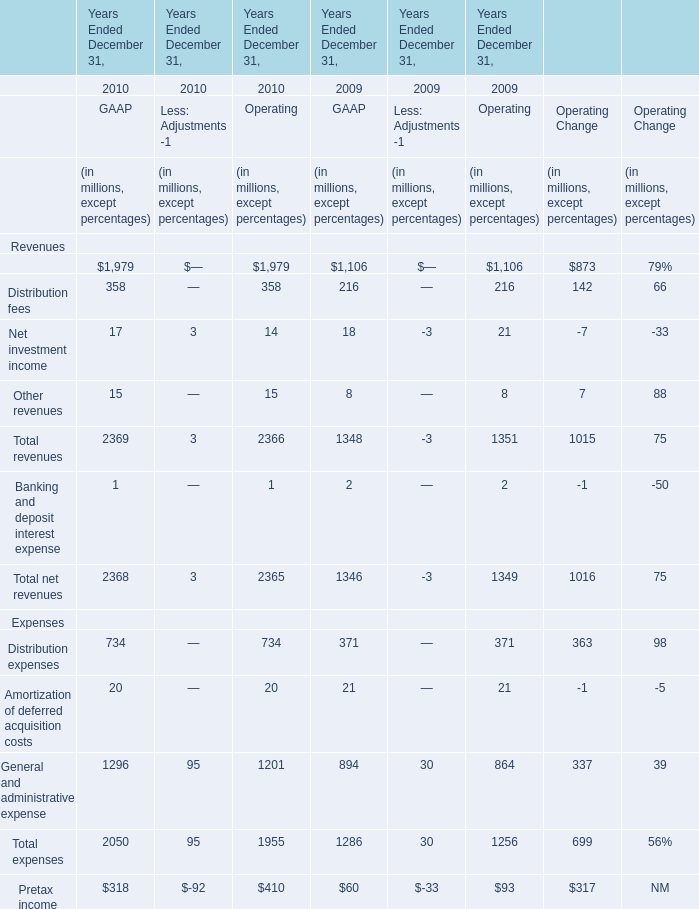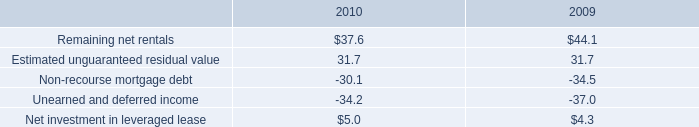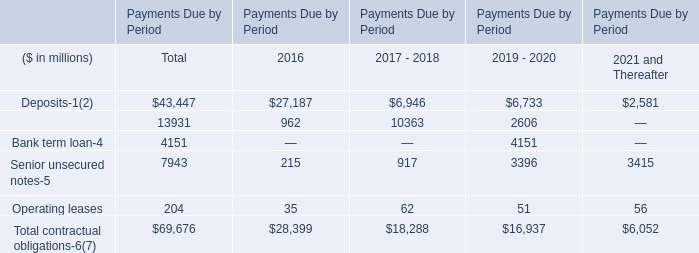What will total revenues of GAAP be like in 2011 if it develops with the same increasing rate as current? (in dollars in millions) 
Computations: (2369 * (1 + ((2369 - 1348) / 1348)))
Answer: 4163.32418. 